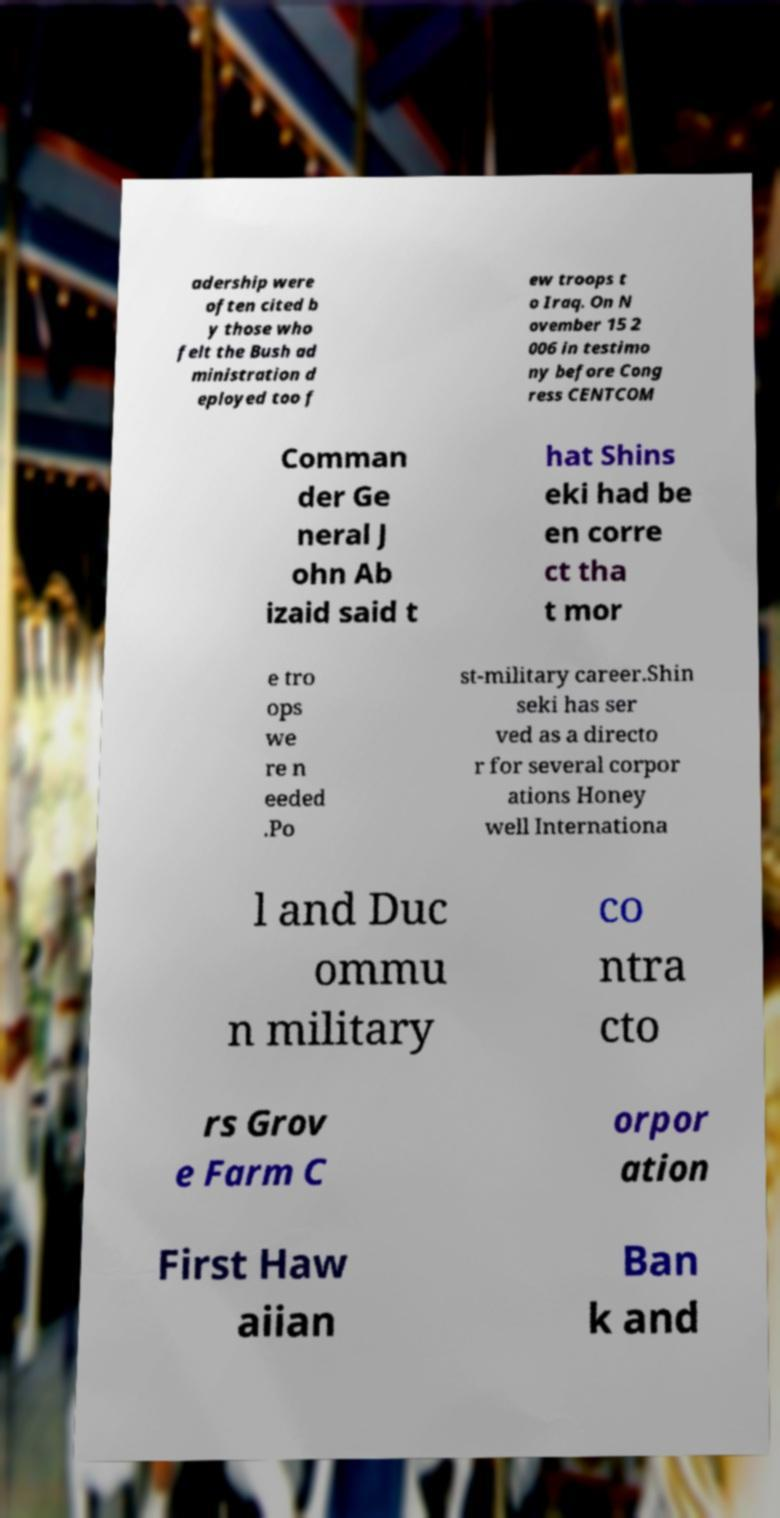I need the written content from this picture converted into text. Can you do that? adership were often cited b y those who felt the Bush ad ministration d eployed too f ew troops t o Iraq. On N ovember 15 2 006 in testimo ny before Cong ress CENTCOM Comman der Ge neral J ohn Ab izaid said t hat Shins eki had be en corre ct tha t mor e tro ops we re n eeded .Po st-military career.Shin seki has ser ved as a directo r for several corpor ations Honey well Internationa l and Duc ommu n military co ntra cto rs Grov e Farm C orpor ation First Haw aiian Ban k and 